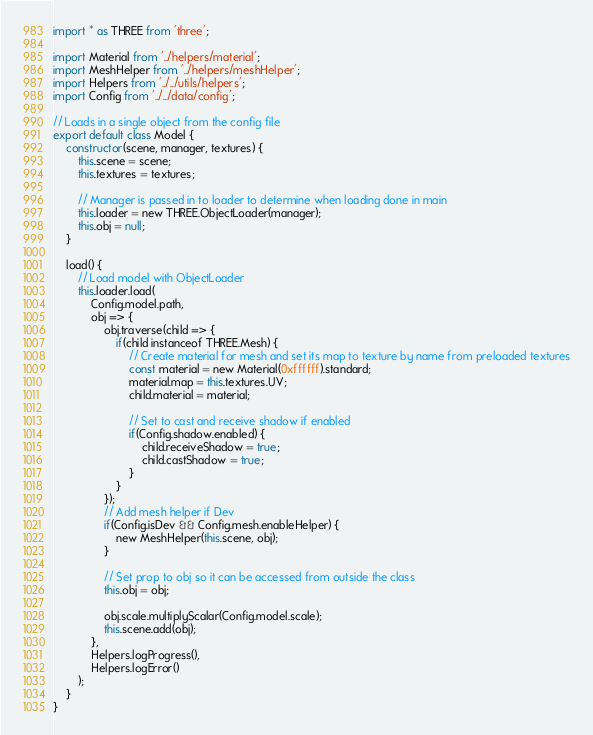<code> <loc_0><loc_0><loc_500><loc_500><_JavaScript_>import * as THREE from 'three';

import Material from '../helpers/material';
import MeshHelper from '../helpers/meshHelper';
import Helpers from '../../utils/helpers';
import Config from '../../data/config';

// Loads in a single object from the config file
export default class Model {
    constructor(scene, manager, textures) {
        this.scene = scene;
        this.textures = textures;

        // Manager is passed in to loader to determine when loading done in main
        this.loader = new THREE.ObjectLoader(manager);
        this.obj = null;
    }

    load() {
        // Load model with ObjectLoader
        this.loader.load(
            Config.model.path,
            obj => {
                obj.traverse(child => {
                    if(child instanceof THREE.Mesh) {
                        // Create material for mesh and set its map to texture by name from preloaded textures
                        const material = new Material(0xffffff).standard;
                        material.map = this.textures.UV;
                        child.material = material;

                        // Set to cast and receive shadow if enabled
                        if(Config.shadow.enabled) {
                            child.receiveShadow = true;
                            child.castShadow = true;
                        }
                    }
                });
                // Add mesh helper if Dev
                if(Config.isDev && Config.mesh.enableHelper) {
                    new MeshHelper(this.scene, obj);
                }

                // Set prop to obj so it can be accessed from outside the class
                this.obj = obj;

                obj.scale.multiplyScalar(Config.model.scale);
                this.scene.add(obj);
            },
            Helpers.logProgress(),
            Helpers.logError()
        );
    }
}
</code> 